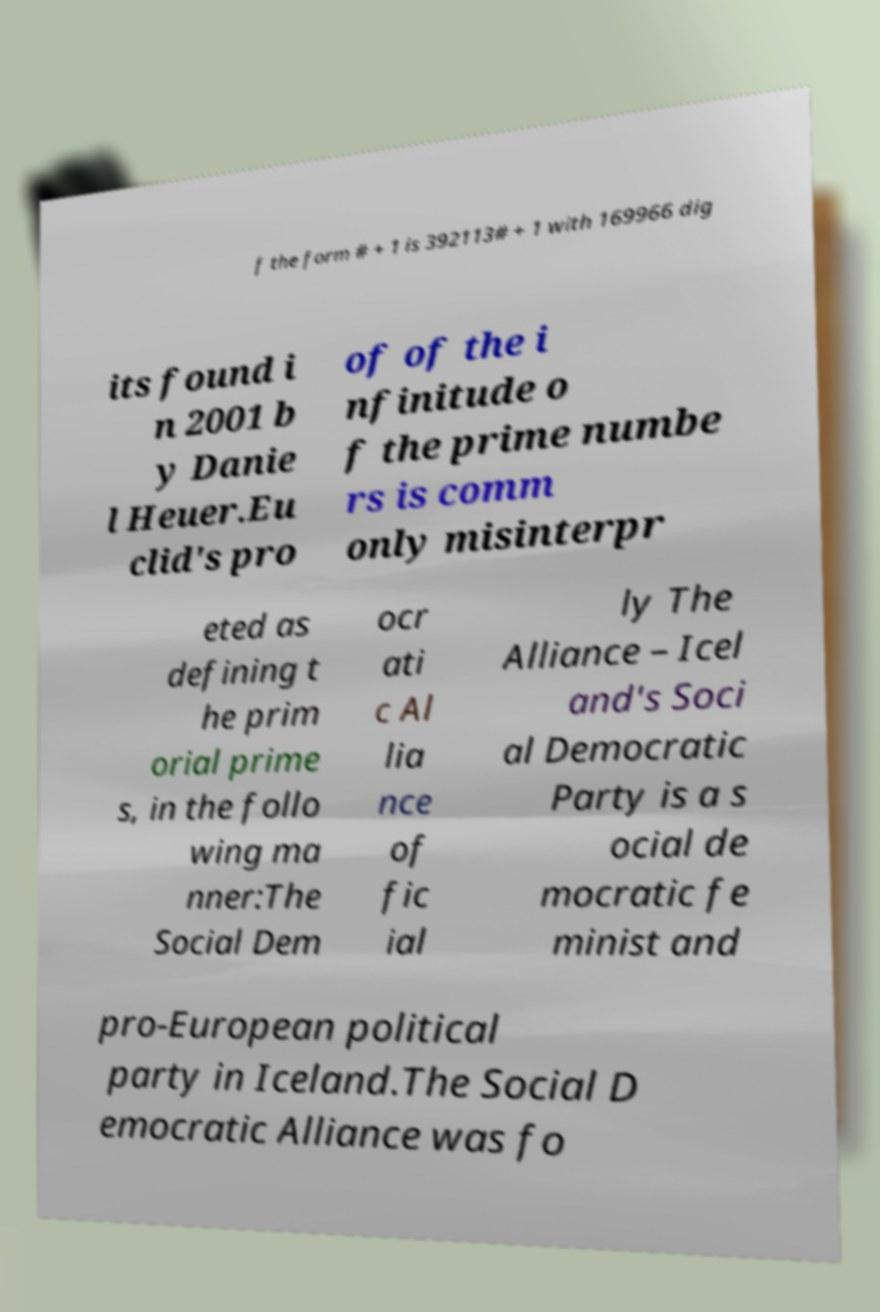Please identify and transcribe the text found in this image. f the form # + 1 is 392113# + 1 with 169966 dig its found i n 2001 b y Danie l Heuer.Eu clid's pro of of the i nfinitude o f the prime numbe rs is comm only misinterpr eted as defining t he prim orial prime s, in the follo wing ma nner:The Social Dem ocr ati c Al lia nce of fic ial ly The Alliance – Icel and's Soci al Democratic Party is a s ocial de mocratic fe minist and pro-European political party in Iceland.The Social D emocratic Alliance was fo 